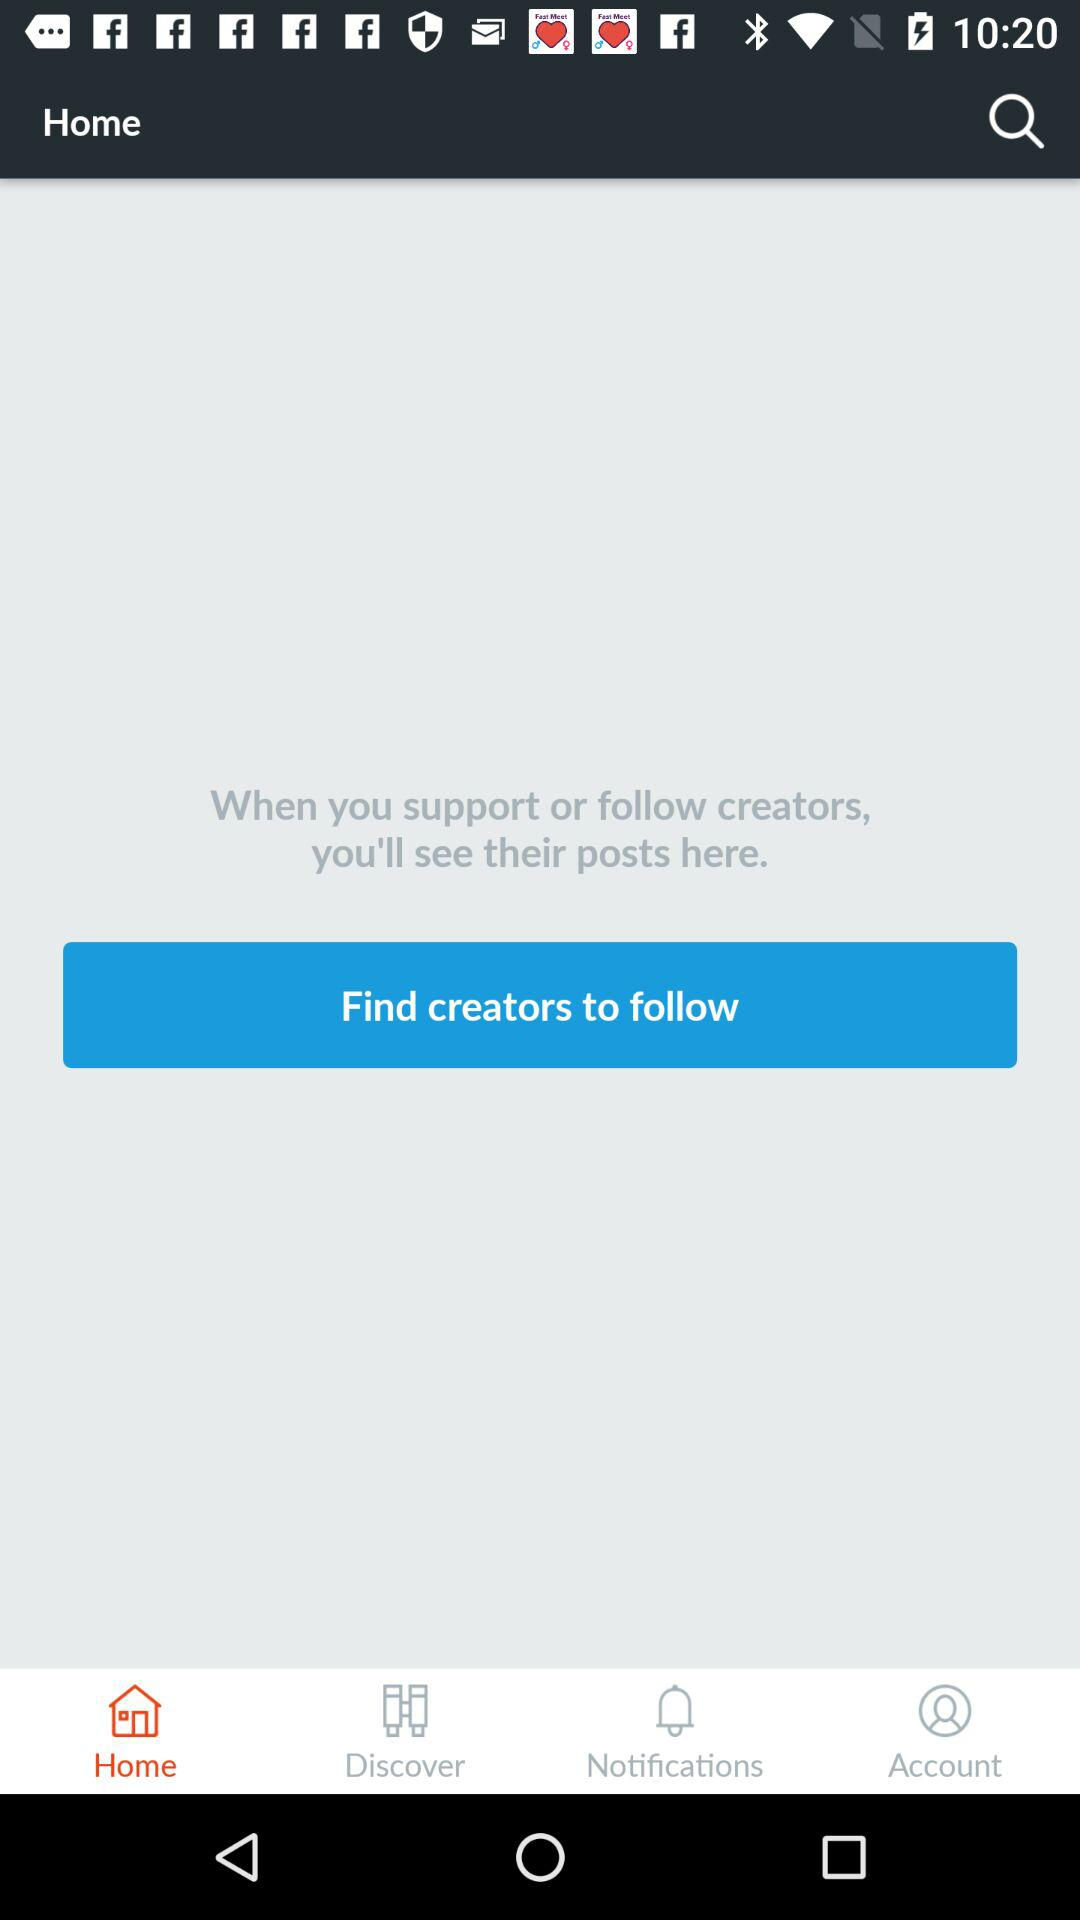Which tab is selected? The selected tab is "Home". 